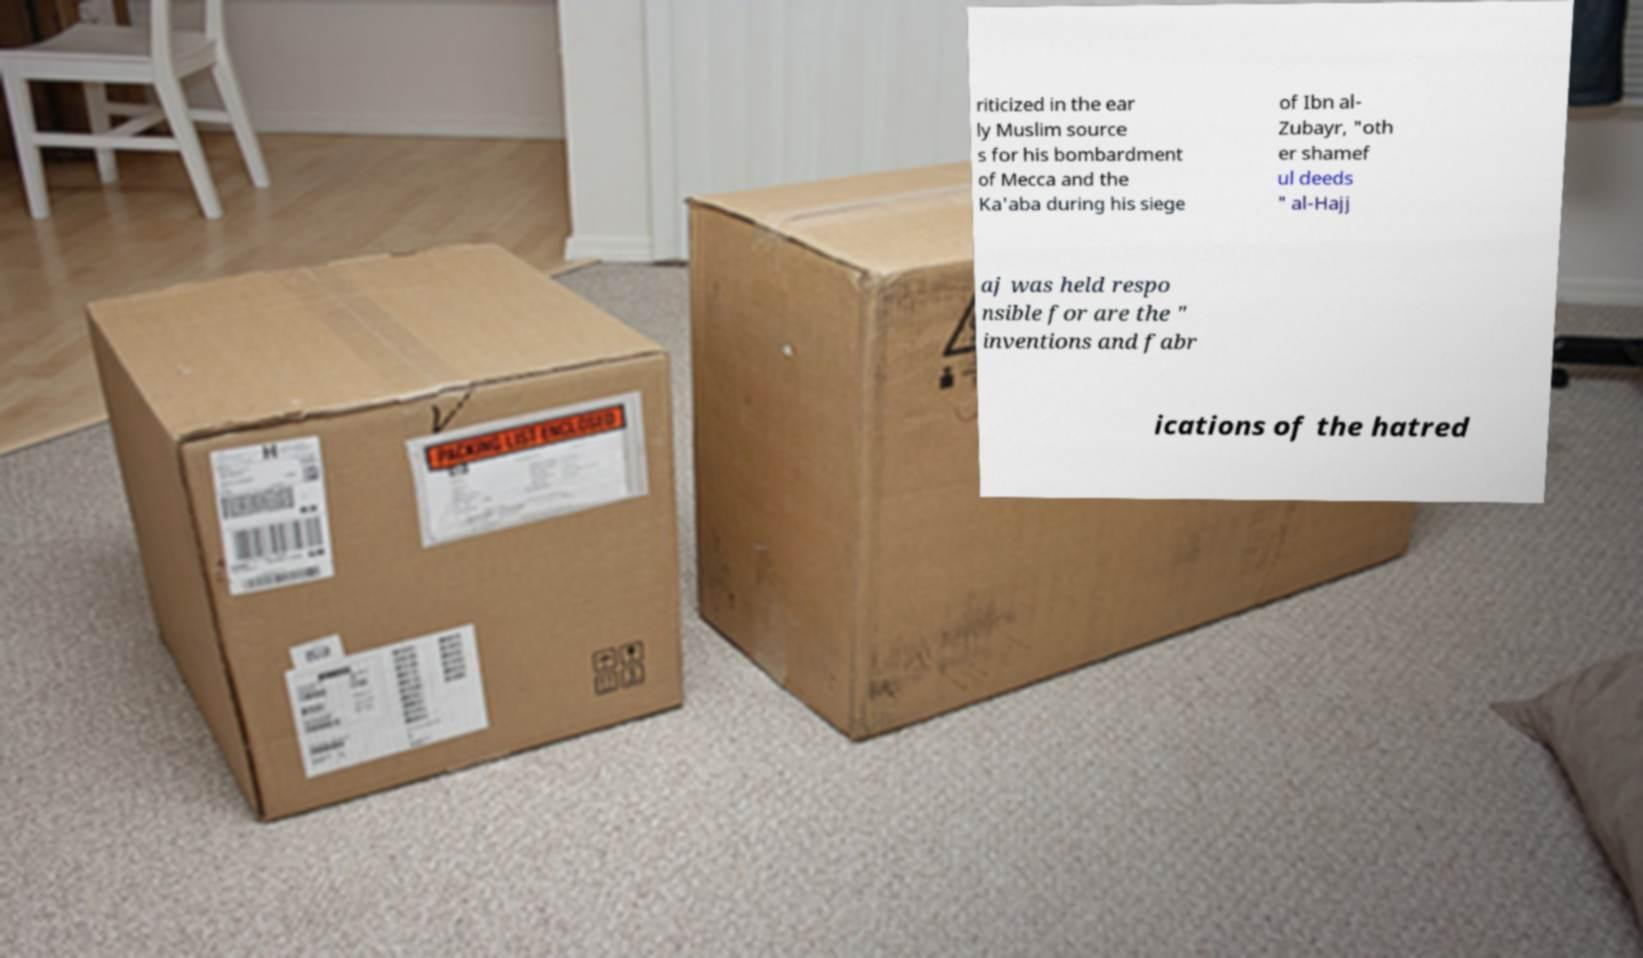Please read and relay the text visible in this image. What does it say? riticized in the ear ly Muslim source s for his bombardment of Mecca and the Ka'aba during his siege of Ibn al- Zubayr, "oth er shamef ul deeds " al-Hajj aj was held respo nsible for are the " inventions and fabr ications of the hatred 